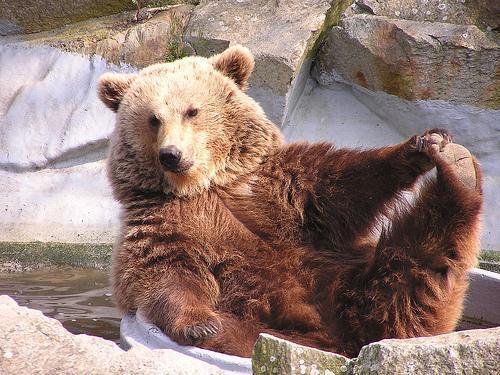How many bears are there?
Give a very brief answer. 1. How many dogs are biting the bear?
Give a very brief answer. 0. 